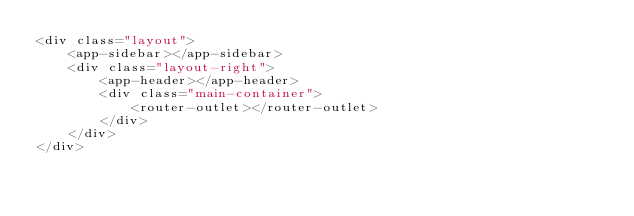Convert code to text. <code><loc_0><loc_0><loc_500><loc_500><_HTML_><div class="layout">
    <app-sidebar></app-sidebar>
    <div class="layout-right">
        <app-header></app-header>
        <div class="main-container">
            <router-outlet></router-outlet>
        </div>
    </div>
</div>
</code> 